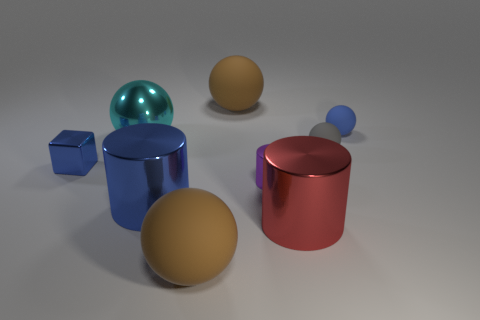Subtract all cyan balls. How many balls are left? 4 Subtract all cyan shiny balls. How many balls are left? 4 Subtract all green cylinders. Subtract all red cubes. How many cylinders are left? 3 Add 1 large brown balls. How many objects exist? 10 Subtract all cylinders. How many objects are left? 6 Subtract all large blue metallic spheres. Subtract all blue cylinders. How many objects are left? 8 Add 8 large red objects. How many large red objects are left? 9 Add 9 small blue spheres. How many small blue spheres exist? 10 Subtract 0 cyan cylinders. How many objects are left? 9 